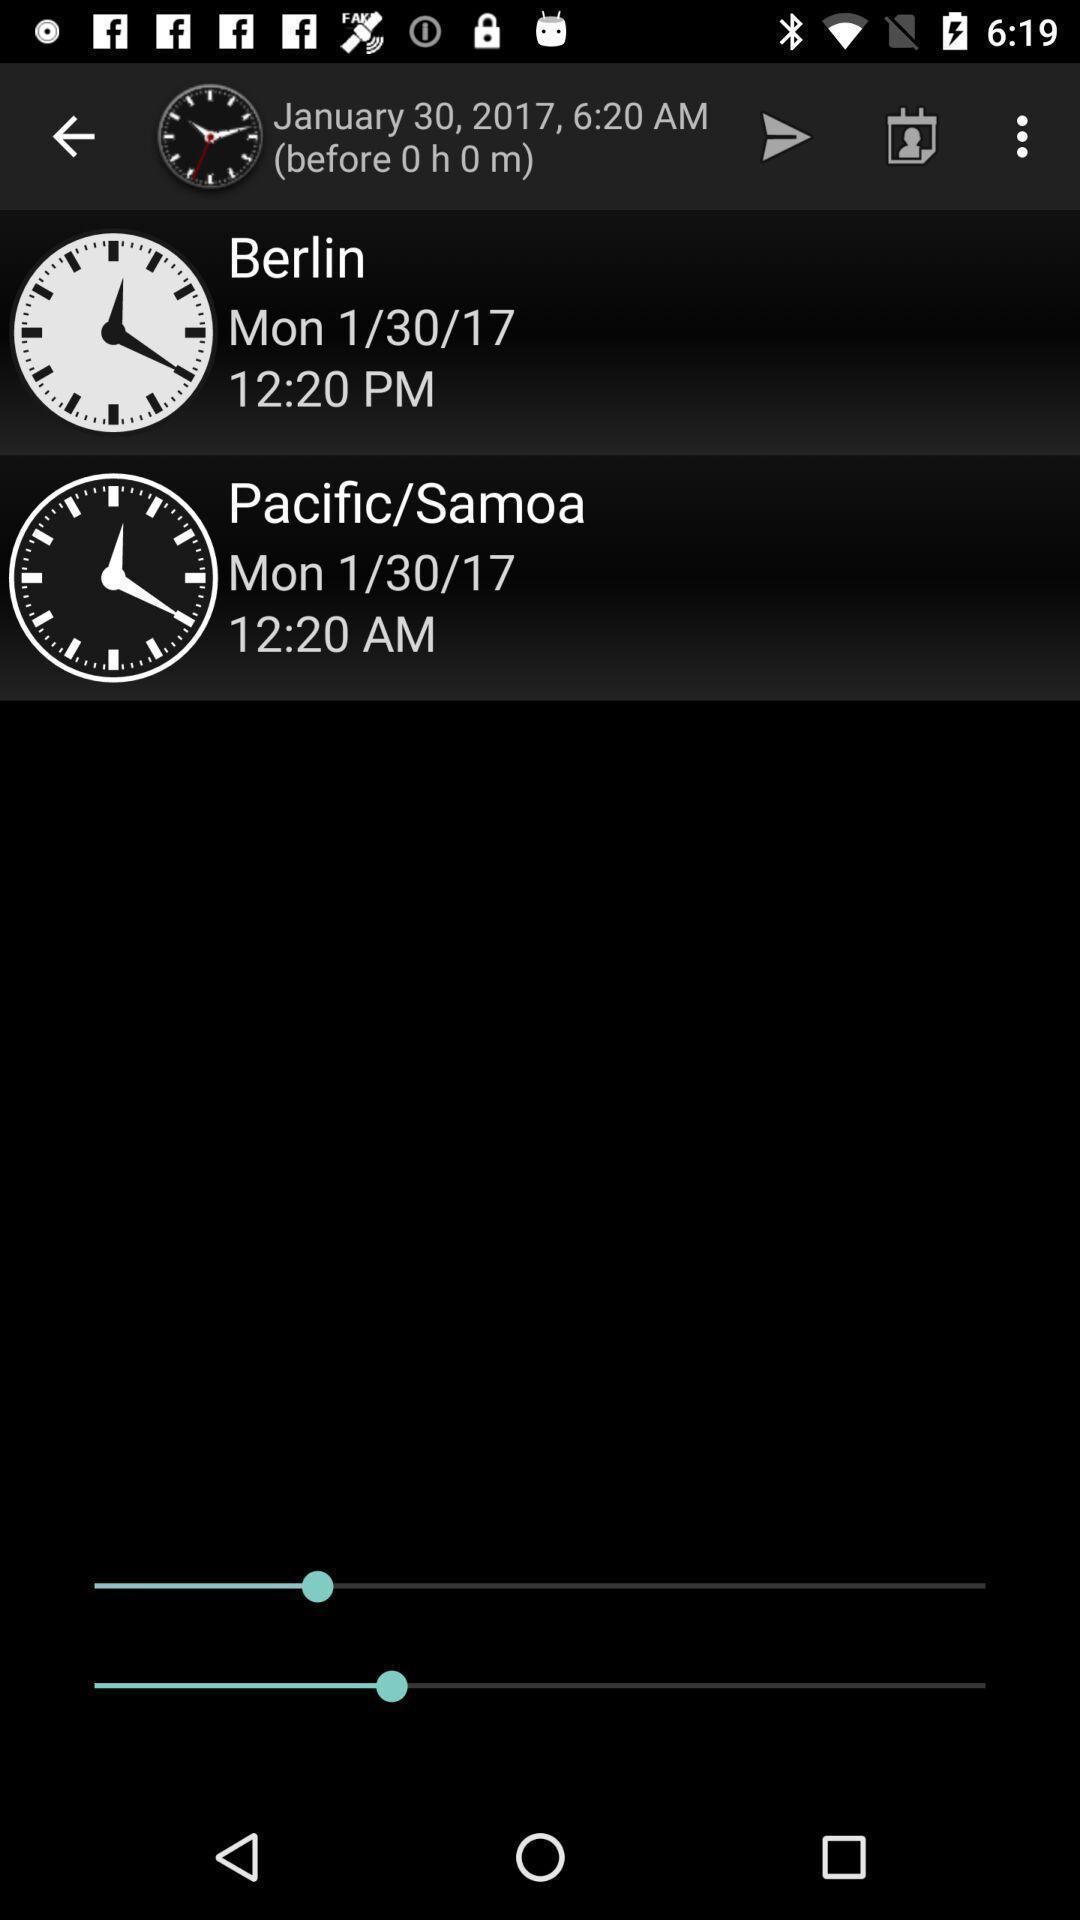What is the overall content of this screenshot? Page showing different location times in clock. 